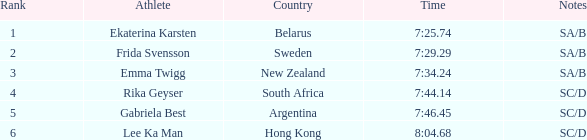What is the overall position for the athlete with a race time of 7:3 1.0. 